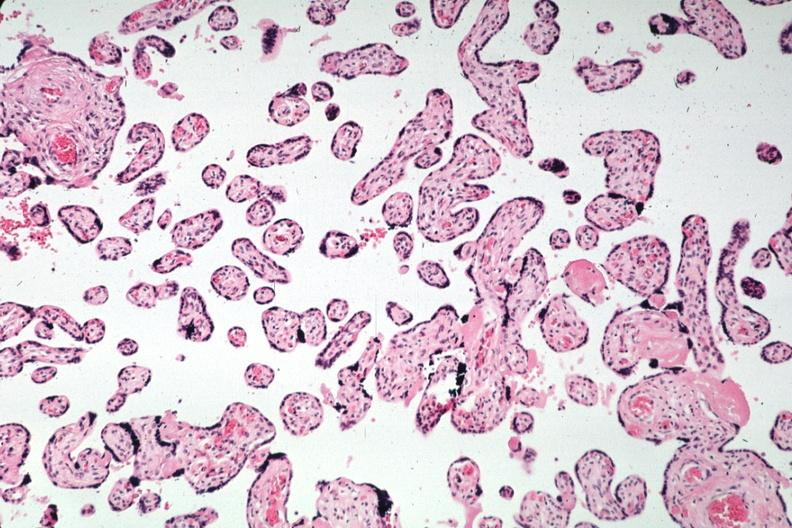s syncytial knots present?
Answer the question using a single word or phrase. Yes 